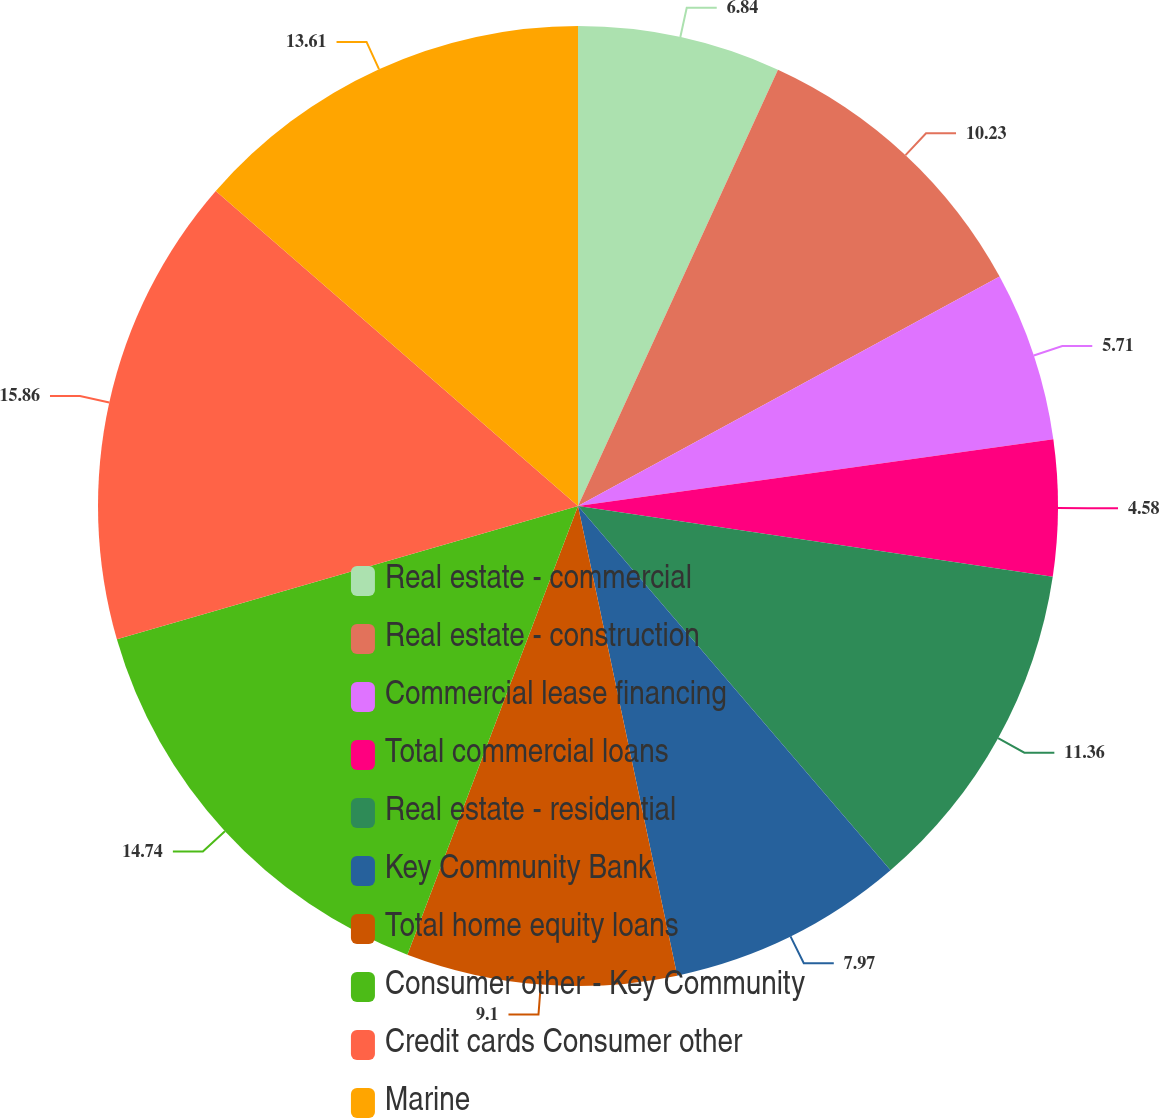Convert chart. <chart><loc_0><loc_0><loc_500><loc_500><pie_chart><fcel>Real estate - commercial<fcel>Real estate - construction<fcel>Commercial lease financing<fcel>Total commercial loans<fcel>Real estate - residential<fcel>Key Community Bank<fcel>Total home equity loans<fcel>Consumer other - Key Community<fcel>Credit cards Consumer other<fcel>Marine<nl><fcel>6.84%<fcel>10.23%<fcel>5.71%<fcel>4.58%<fcel>11.36%<fcel>7.97%<fcel>9.1%<fcel>14.74%<fcel>15.87%<fcel>13.61%<nl></chart> 